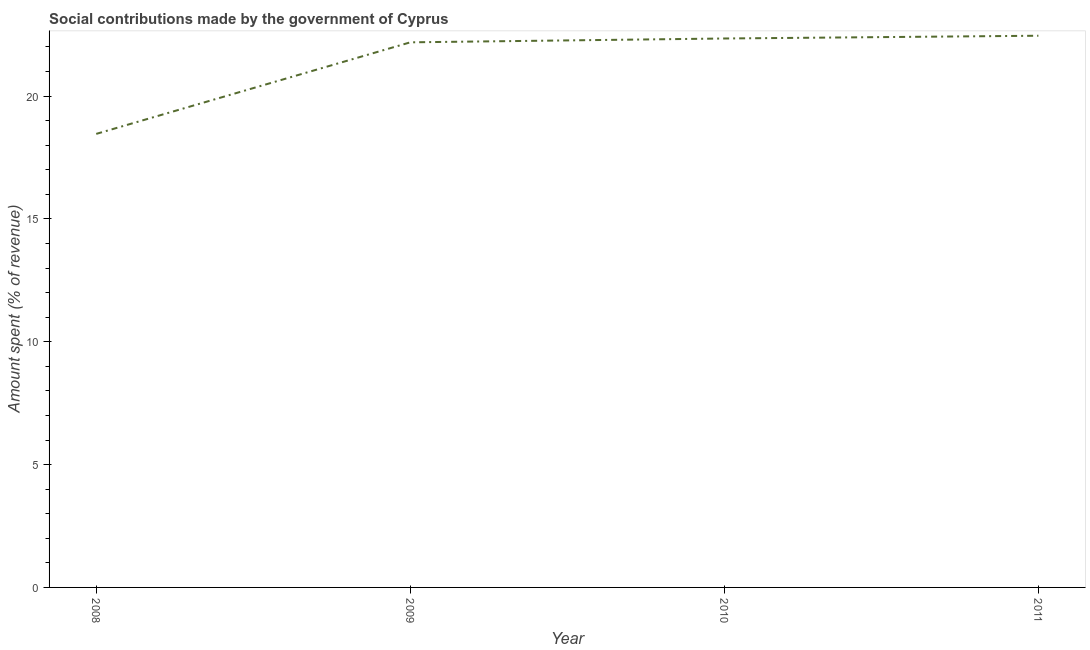What is the amount spent in making social contributions in 2011?
Ensure brevity in your answer.  22.46. Across all years, what is the maximum amount spent in making social contributions?
Offer a terse response. 22.46. Across all years, what is the minimum amount spent in making social contributions?
Provide a short and direct response. 18.46. In which year was the amount spent in making social contributions maximum?
Make the answer very short. 2011. What is the sum of the amount spent in making social contributions?
Your answer should be compact. 85.46. What is the difference between the amount spent in making social contributions in 2010 and 2011?
Provide a short and direct response. -0.11. What is the average amount spent in making social contributions per year?
Your answer should be very brief. 21.36. What is the median amount spent in making social contributions?
Provide a succinct answer. 22.27. Do a majority of the years between 2011 and 2008 (inclusive) have amount spent in making social contributions greater than 17 %?
Offer a terse response. Yes. What is the ratio of the amount spent in making social contributions in 2009 to that in 2010?
Your answer should be compact. 0.99. Is the amount spent in making social contributions in 2009 less than that in 2011?
Give a very brief answer. Yes. What is the difference between the highest and the second highest amount spent in making social contributions?
Offer a terse response. 0.11. Is the sum of the amount spent in making social contributions in 2010 and 2011 greater than the maximum amount spent in making social contributions across all years?
Make the answer very short. Yes. What is the difference between the highest and the lowest amount spent in making social contributions?
Your response must be concise. 4. Does the amount spent in making social contributions monotonically increase over the years?
Offer a terse response. Yes. How many lines are there?
Provide a short and direct response. 1. What is the difference between two consecutive major ticks on the Y-axis?
Your response must be concise. 5. Are the values on the major ticks of Y-axis written in scientific E-notation?
Ensure brevity in your answer.  No. Does the graph contain grids?
Your answer should be very brief. No. What is the title of the graph?
Ensure brevity in your answer.  Social contributions made by the government of Cyprus. What is the label or title of the X-axis?
Make the answer very short. Year. What is the label or title of the Y-axis?
Provide a short and direct response. Amount spent (% of revenue). What is the Amount spent (% of revenue) in 2008?
Your answer should be very brief. 18.46. What is the Amount spent (% of revenue) in 2009?
Your answer should be very brief. 22.19. What is the Amount spent (% of revenue) of 2010?
Offer a terse response. 22.35. What is the Amount spent (% of revenue) of 2011?
Ensure brevity in your answer.  22.46. What is the difference between the Amount spent (% of revenue) in 2008 and 2009?
Offer a terse response. -3.73. What is the difference between the Amount spent (% of revenue) in 2008 and 2010?
Offer a terse response. -3.88. What is the difference between the Amount spent (% of revenue) in 2008 and 2011?
Your answer should be very brief. -4. What is the difference between the Amount spent (% of revenue) in 2009 and 2010?
Ensure brevity in your answer.  -0.16. What is the difference between the Amount spent (% of revenue) in 2009 and 2011?
Your answer should be compact. -0.27. What is the difference between the Amount spent (% of revenue) in 2010 and 2011?
Your response must be concise. -0.11. What is the ratio of the Amount spent (% of revenue) in 2008 to that in 2009?
Provide a short and direct response. 0.83. What is the ratio of the Amount spent (% of revenue) in 2008 to that in 2010?
Offer a very short reply. 0.83. What is the ratio of the Amount spent (% of revenue) in 2008 to that in 2011?
Keep it short and to the point. 0.82. What is the ratio of the Amount spent (% of revenue) in 2009 to that in 2010?
Provide a short and direct response. 0.99. What is the ratio of the Amount spent (% of revenue) in 2009 to that in 2011?
Your answer should be compact. 0.99. What is the ratio of the Amount spent (% of revenue) in 2010 to that in 2011?
Give a very brief answer. 0.99. 